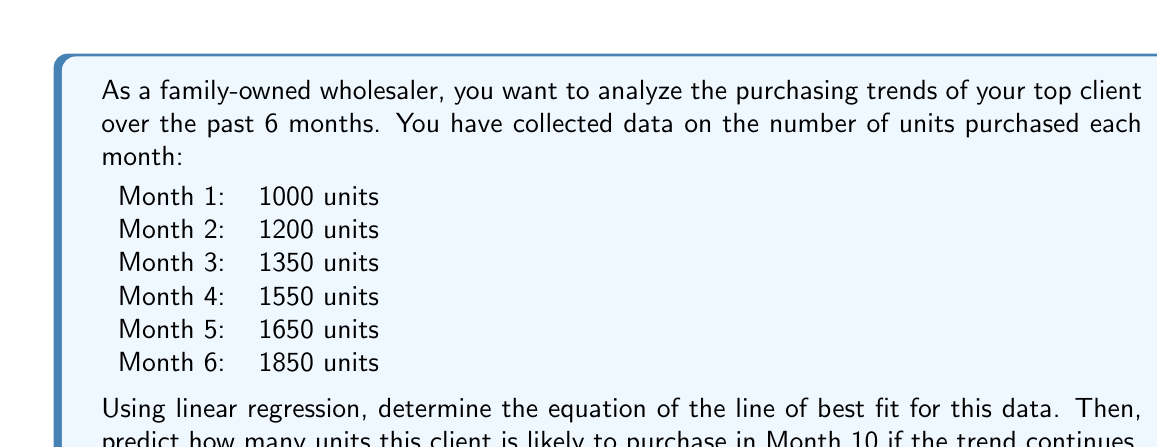Provide a solution to this math problem. To solve this problem, we'll use the linear regression method to find the line of best fit, then use that equation to predict future purchases.

Step 1: Set up the data
Let x represent the month number and y represent the number of units purchased.
$$(x_1, y_1) = (1, 1000), (x_2, y_2) = (2, 1200), ..., (x_6, y_6) = (6, 1850)$$

Step 2: Calculate the means of x and y
$$\bar{x} = \frac{1 + 2 + 3 + 4 + 5 + 6}{6} = 3.5$$
$$\bar{y} = \frac{1000 + 1200 + 1350 + 1550 + 1650 + 1850}{6} = 1433.33$$

Step 3: Calculate the slope (m) using the formula:
$$m = \frac{\sum(x_i - \bar{x})(y_i - \bar{y})}{\sum(x_i - \bar{x})^2}$$

$$m = \frac{(-2.5)(-433.33) + (-1.5)(-233.33) + ...}{(-2.5)^2 + (-1.5)^2 + ...}$$
$$m = \frac{2916.67}{17.5} = 166.67$$

Step 4: Calculate the y-intercept (b) using the formula:
$$b = \bar{y} - m\bar{x}$$
$$b = 1433.33 - 166.67(3.5) = 850$$

Step 5: Write the equation of the line of best fit
$$y = mx + b$$
$$y = 166.67x + 850$$

Step 6: Predict the number of units for Month 10
$$y = 166.67(10) + 850 = 2516.7$$

Therefore, the client is likely to purchase approximately 2517 units in Month 10 if the trend continues.
Answer: The equation of the line of best fit is $y = 166.67x + 850$, where x is the month number and y is the number of units purchased. The predicted number of units to be purchased in Month 10 is approximately 2517 units. 